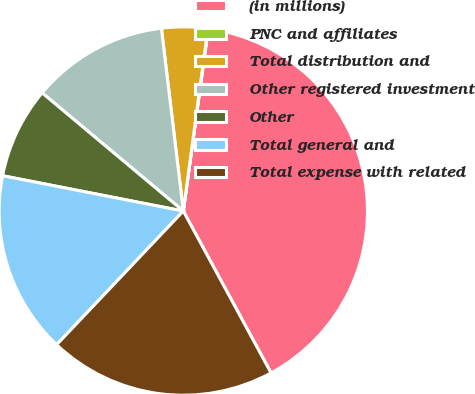Convert chart to OTSL. <chart><loc_0><loc_0><loc_500><loc_500><pie_chart><fcel>(in millions)<fcel>PNC and affiliates<fcel>Total distribution and<fcel>Other registered investment<fcel>Other<fcel>Total general and<fcel>Total expense with related<nl><fcel>39.93%<fcel>0.04%<fcel>4.03%<fcel>12.01%<fcel>8.02%<fcel>16.0%<fcel>19.98%<nl></chart> 